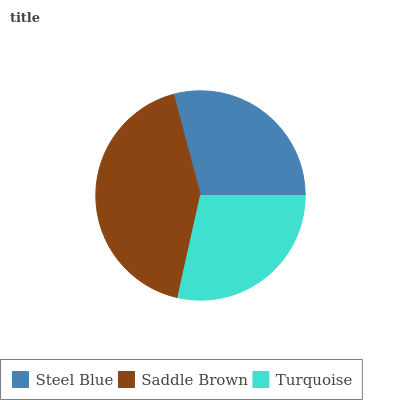Is Turquoise the minimum?
Answer yes or no. Yes. Is Saddle Brown the maximum?
Answer yes or no. Yes. Is Saddle Brown the minimum?
Answer yes or no. No. Is Turquoise the maximum?
Answer yes or no. No. Is Saddle Brown greater than Turquoise?
Answer yes or no. Yes. Is Turquoise less than Saddle Brown?
Answer yes or no. Yes. Is Turquoise greater than Saddle Brown?
Answer yes or no. No. Is Saddle Brown less than Turquoise?
Answer yes or no. No. Is Steel Blue the high median?
Answer yes or no. Yes. Is Steel Blue the low median?
Answer yes or no. Yes. Is Saddle Brown the high median?
Answer yes or no. No. Is Saddle Brown the low median?
Answer yes or no. No. 